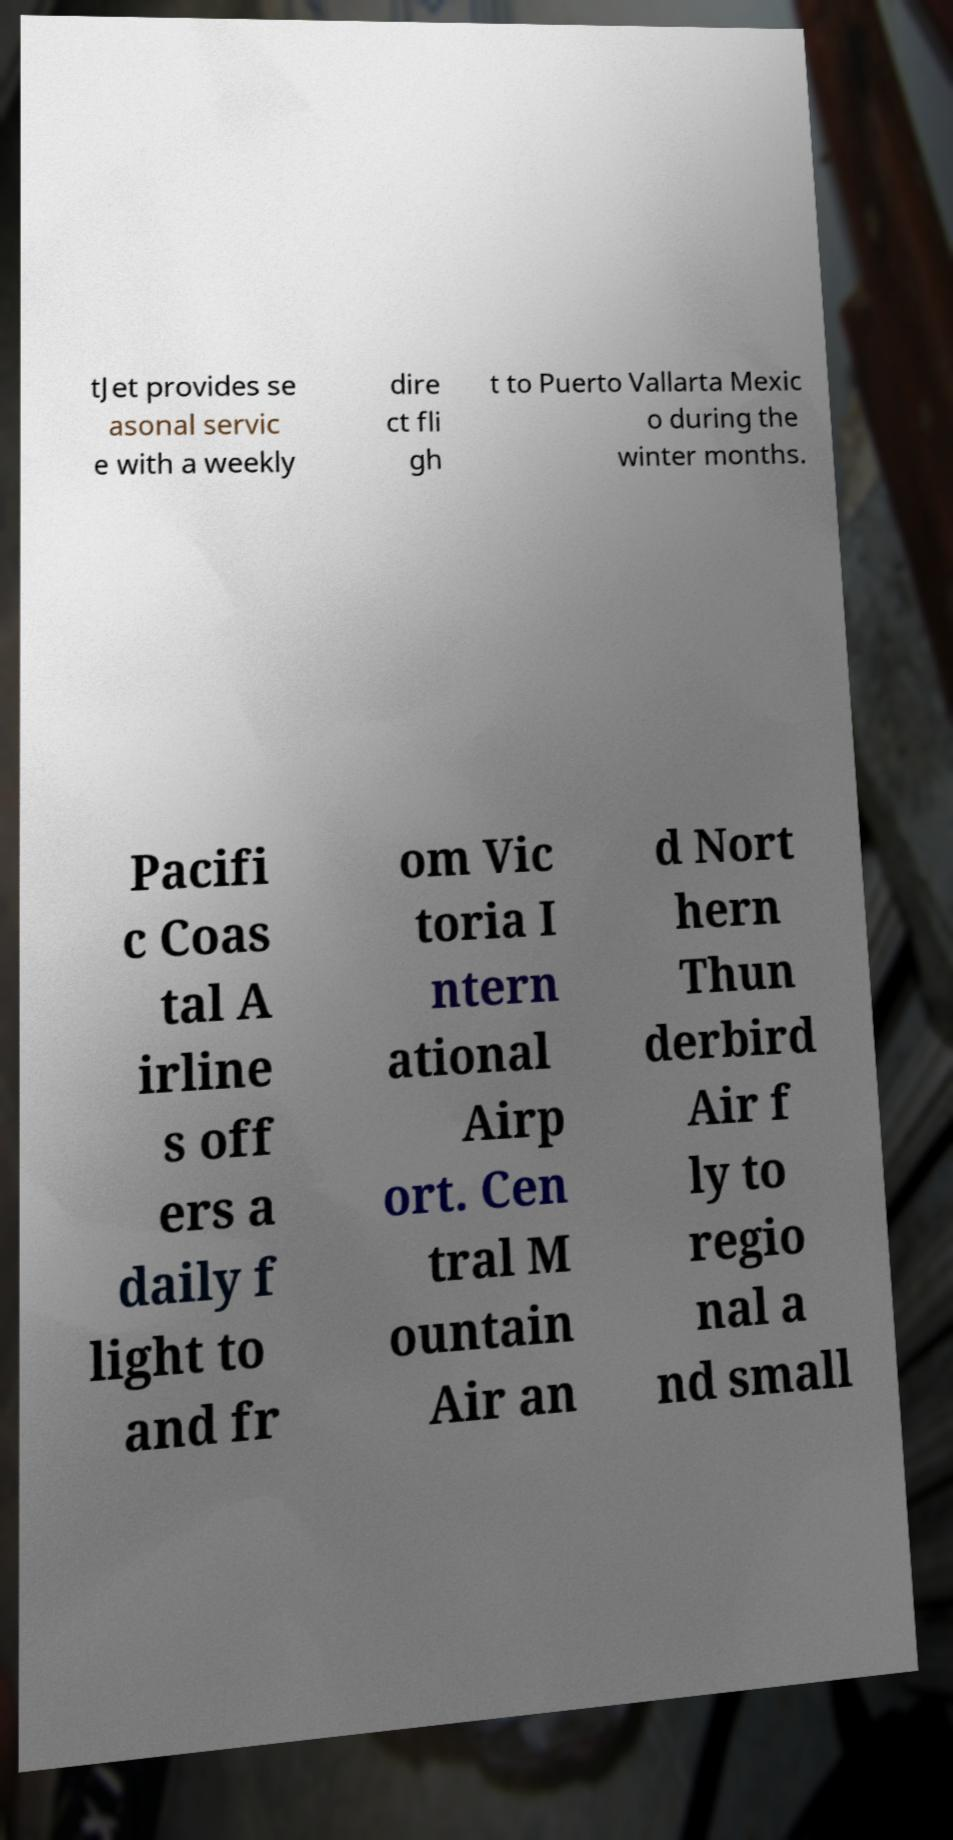There's text embedded in this image that I need extracted. Can you transcribe it verbatim? tJet provides se asonal servic e with a weekly dire ct fli gh t to Puerto Vallarta Mexic o during the winter months. Pacifi c Coas tal A irline s off ers a daily f light to and fr om Vic toria I ntern ational Airp ort. Cen tral M ountain Air an d Nort hern Thun derbird Air f ly to regio nal a nd small 